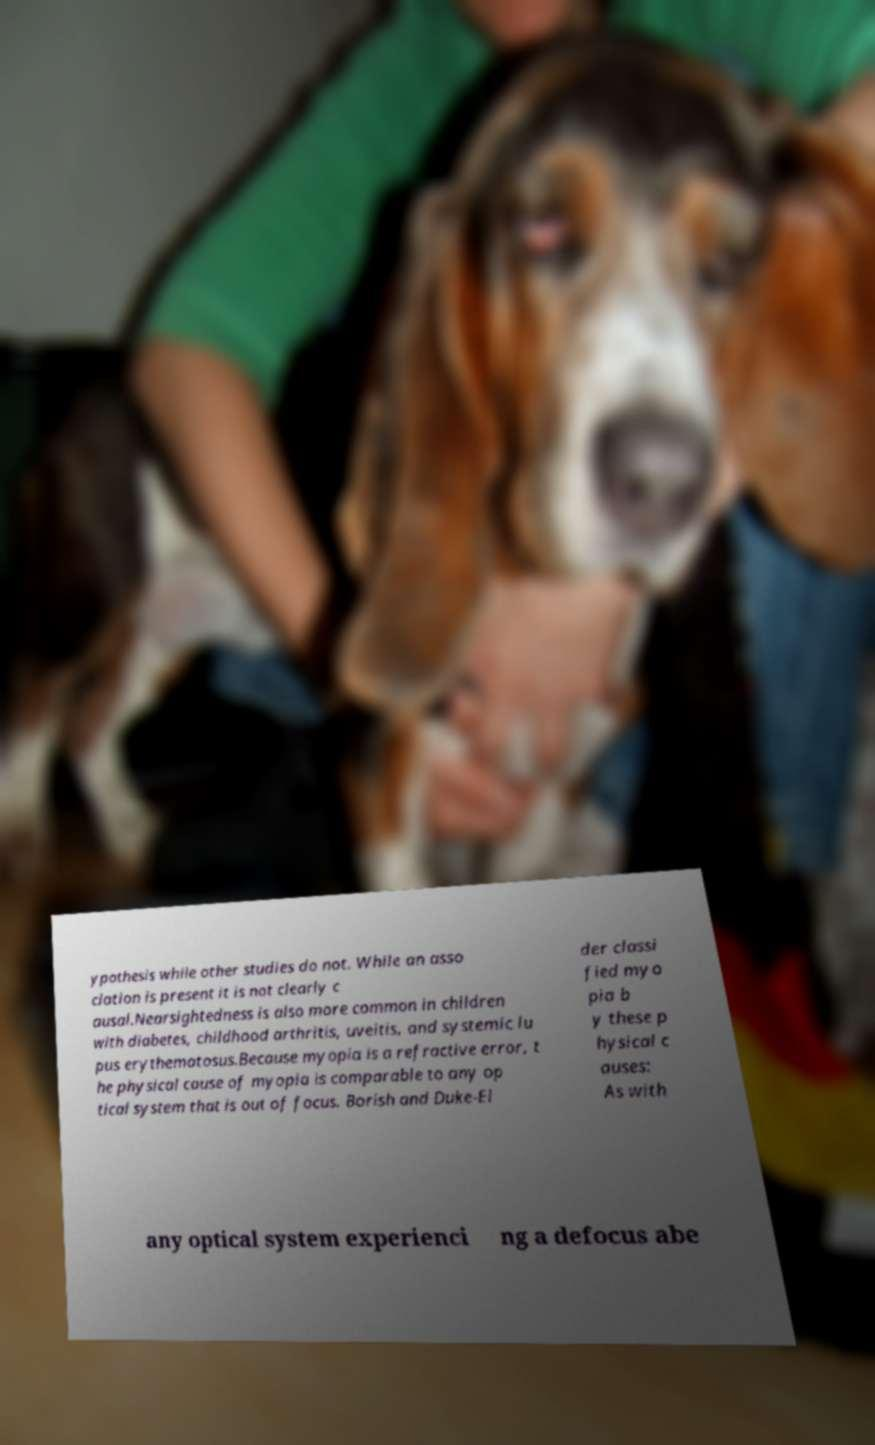There's text embedded in this image that I need extracted. Can you transcribe it verbatim? ypothesis while other studies do not. While an asso ciation is present it is not clearly c ausal.Nearsightedness is also more common in children with diabetes, childhood arthritis, uveitis, and systemic lu pus erythematosus.Because myopia is a refractive error, t he physical cause of myopia is comparable to any op tical system that is out of focus. Borish and Duke-El der classi fied myo pia b y these p hysical c auses: As with any optical system experienci ng a defocus abe 